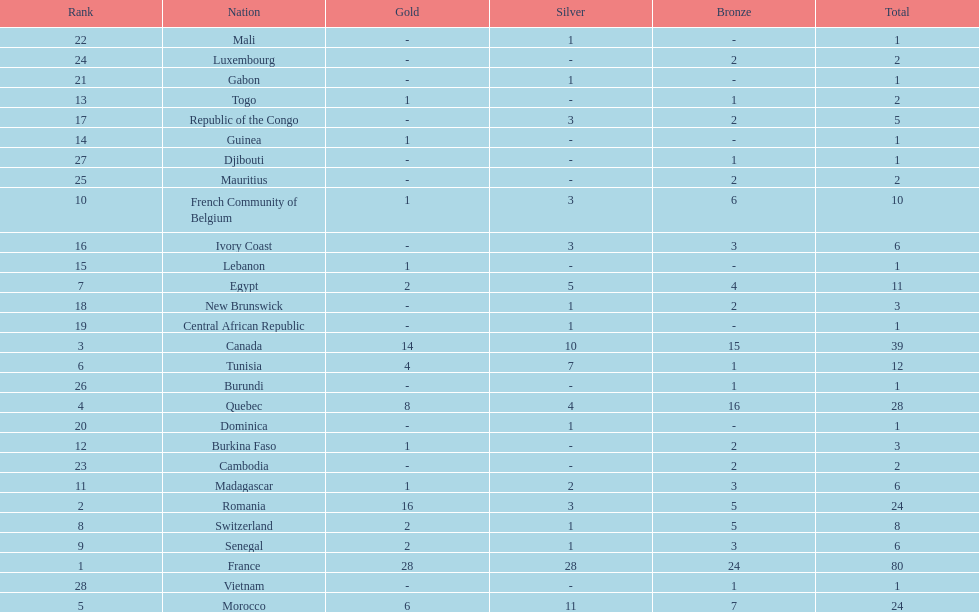How many more medals did egypt win than ivory coast? 5. 